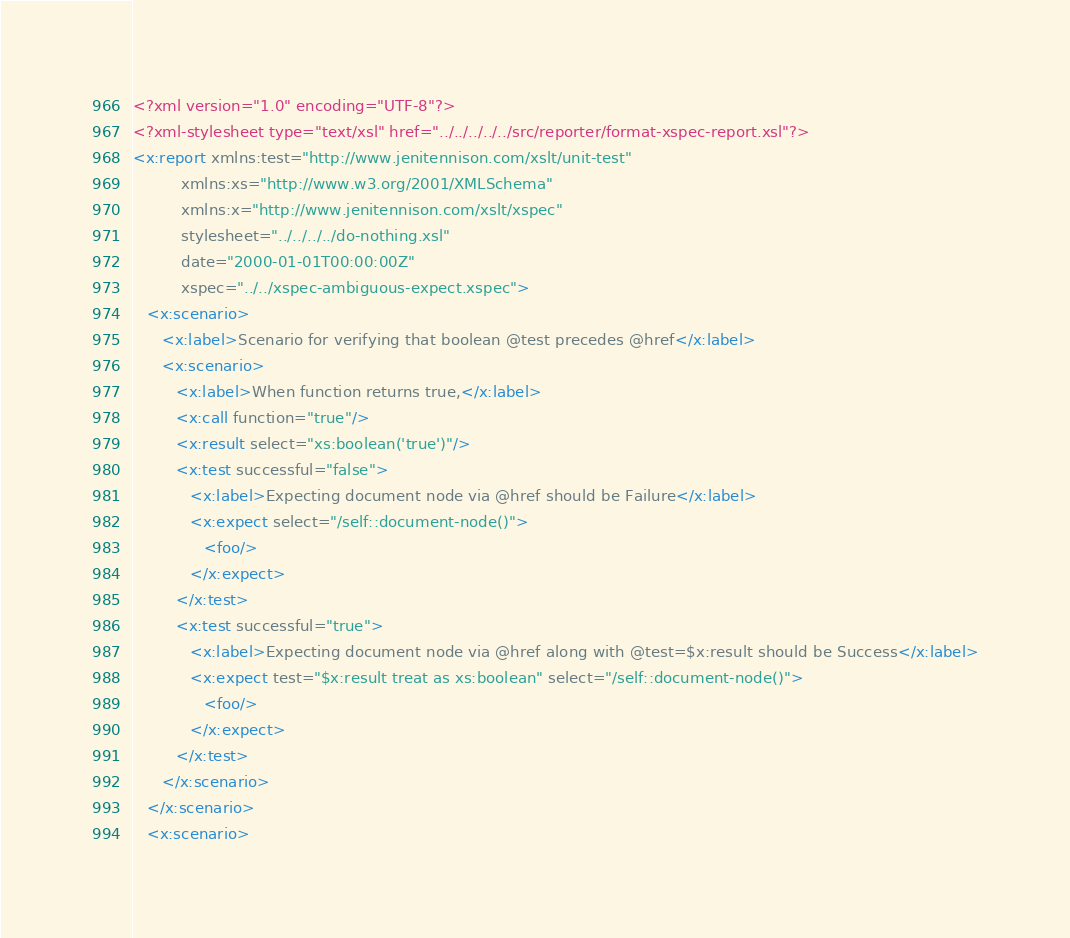Convert code to text. <code><loc_0><loc_0><loc_500><loc_500><_XML_><?xml version="1.0" encoding="UTF-8"?>
<?xml-stylesheet type="text/xsl" href="../../../../../src/reporter/format-xspec-report.xsl"?>
<x:report xmlns:test="http://www.jenitennison.com/xslt/unit-test"
          xmlns:xs="http://www.w3.org/2001/XMLSchema"
          xmlns:x="http://www.jenitennison.com/xslt/xspec"
          stylesheet="../../../../do-nothing.xsl"
          date="2000-01-01T00:00:00Z"
          xspec="../../xspec-ambiguous-expect.xspec">
   <x:scenario>
      <x:label>Scenario for verifying that boolean @test precedes @href</x:label>
      <x:scenario>
         <x:label>When function returns true,</x:label>
         <x:call function="true"/>
         <x:result select="xs:boolean('true')"/>
         <x:test successful="false">
            <x:label>Expecting document node via @href should be Failure</x:label>
            <x:expect select="/self::document-node()">
               <foo/>
            </x:expect>
         </x:test>
         <x:test successful="true">
            <x:label>Expecting document node via @href along with @test=$x:result should be Success</x:label>
            <x:expect test="$x:result treat as xs:boolean" select="/self::document-node()">
               <foo/>
            </x:expect>
         </x:test>
      </x:scenario>
   </x:scenario>
   <x:scenario></code> 